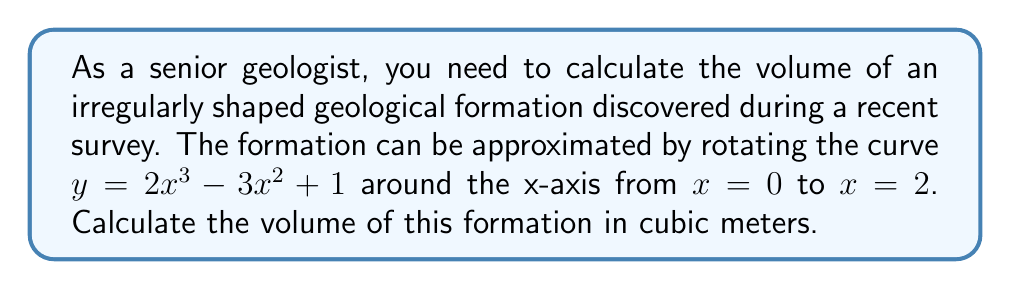Give your solution to this math problem. To calculate the volume of the irregularly shaped geological formation, we need to use the method of integration for volumes of revolution. Specifically, we'll use the disk method since we're rotating around the x-axis.

Step 1: Set up the integral
The volume formula using the disk method is:
$$V = \pi \int_a^b [f(x)]^2 dx$$
where $f(x) = 2x^3 - 3x^2 + 1$, $a = 0$, and $b = 2$.

Step 2: Substitute the function and limits
$$V = \pi \int_0^2 (2x^3 - 3x^2 + 1)^2 dx$$

Step 3: Expand the squared term
$$(2x^3 - 3x^2 + 1)^2 = 4x^6 - 12x^5 + 4x^3 + 9x^4 - 6x^2 + 1$$

Step 4: Set up the expanded integral
$$V = \pi \int_0^2 (4x^6 - 12x^5 + 9x^4 + 4x^3 - 6x^2 + 1) dx$$

Step 5: Integrate each term
$$V = \pi \left[\frac{4x^7}{7} - \frac{12x^6}{6} + \frac{9x^5}{5} + \frac{4x^4}{4} - \frac{6x^3}{3} + x\right]_0^2$$

Step 6: Evaluate the integral at the limits
$$V = \pi \left[\frac{4(2^7)}{7} - \frac{12(2^6)}{6} + \frac{9(2^5)}{5} + \frac{4(2^4)}{4} - \frac{6(2^3)}{3} + 2 - (0)\right]$$

Step 7: Simplify
$$V = \pi \left[\frac{512}{7} - 64 + \frac{288}{5} + 16 - 16 + 2\right]$$
$$V = \pi \left[\frac{512}{7} + \frac{288}{5} - 62\right]$$
$$V \approx 14.514\pi$$

Therefore, the volume of the geological formation is approximately 45.59 cubic meters.
Answer: $45.59 \text{ m}^3$ 